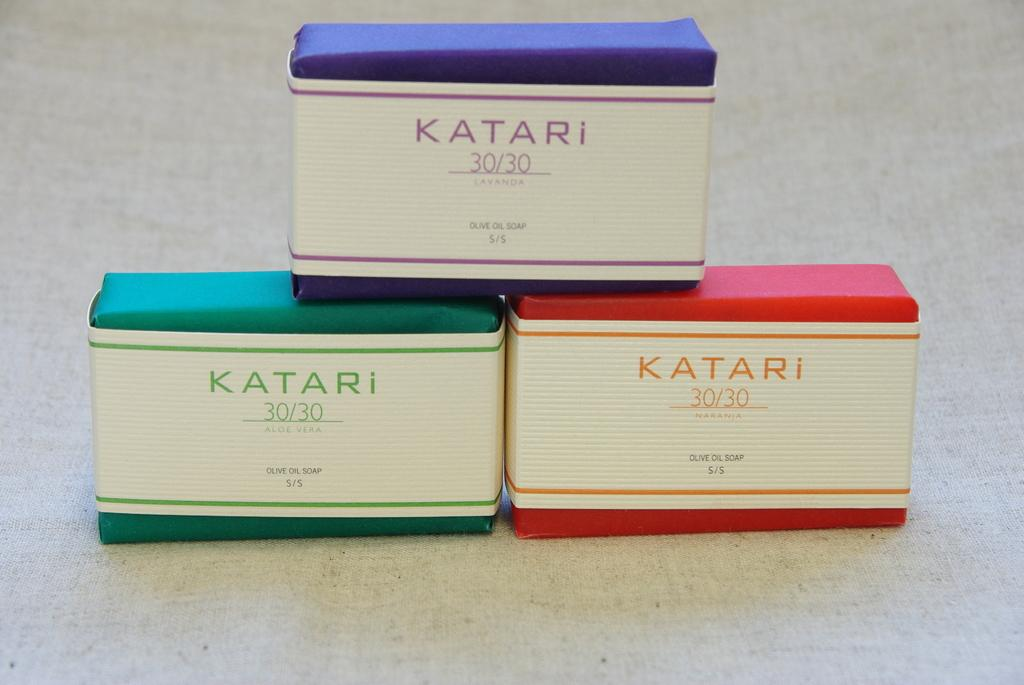<image>
Describe the image concisely. A blue top Katari box is on the green and red top boxes. 